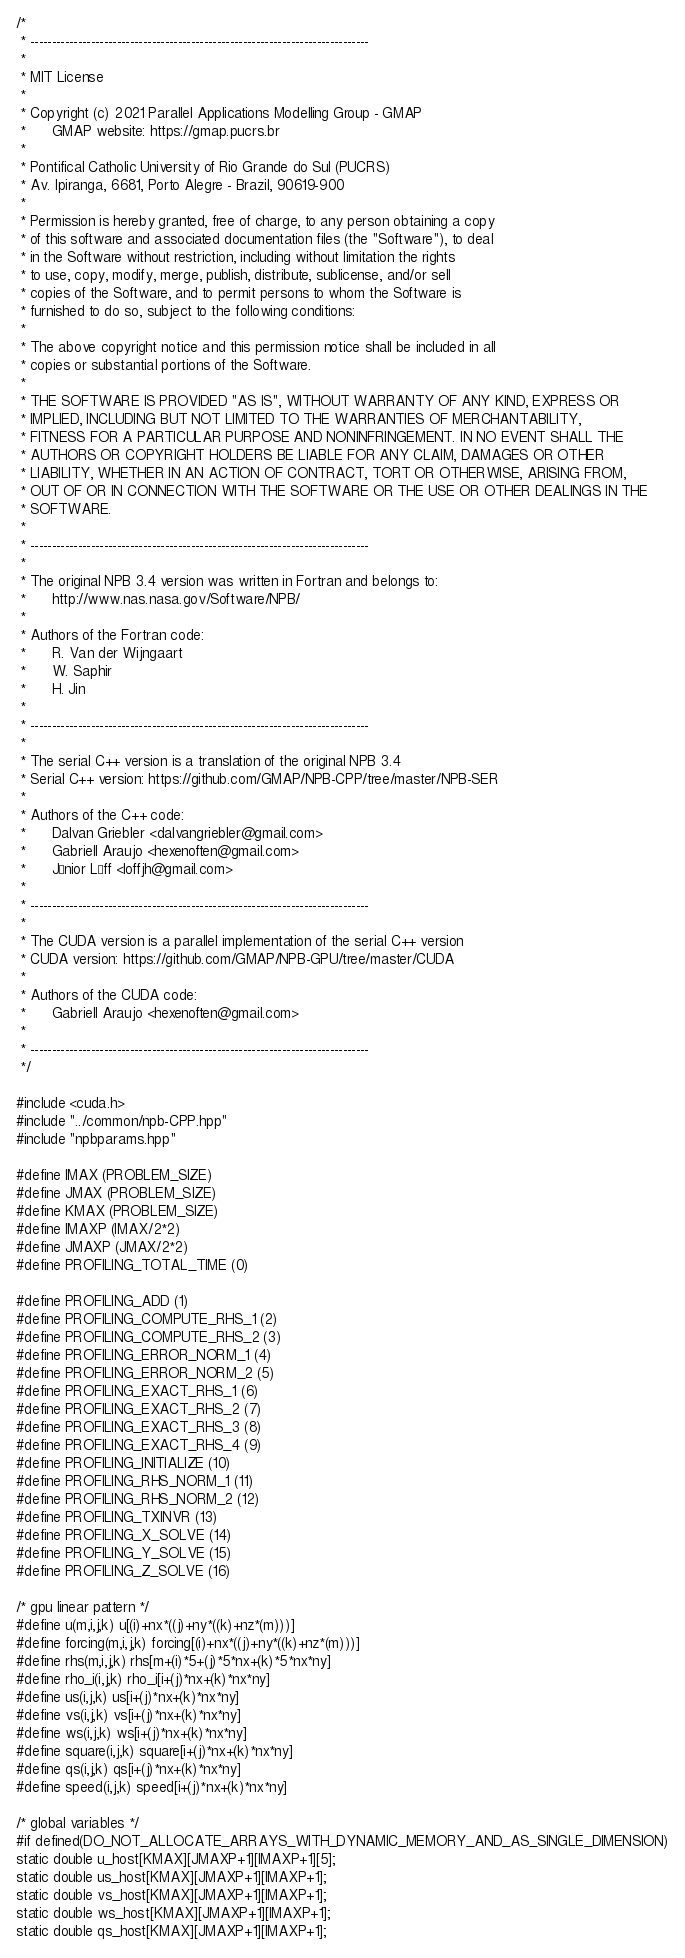Convert code to text. <code><loc_0><loc_0><loc_500><loc_500><_Cuda_>/* 
 * ------------------------------------------------------------------------------
 *
 * MIT License
 *
 * Copyright (c) 2021 Parallel Applications Modelling Group - GMAP
 *      GMAP website: https://gmap.pucrs.br
 *
 * Pontifical Catholic University of Rio Grande do Sul (PUCRS)
 * Av. Ipiranga, 6681, Porto Alegre - Brazil, 90619-900
 *
 * Permission is hereby granted, free of charge, to any person obtaining a copy
 * of this software and associated documentation files (the "Software"), to deal
 * in the Software without restriction, including without limitation the rights
 * to use, copy, modify, merge, publish, distribute, sublicense, and/or sell
 * copies of the Software, and to permit persons to whom the Software is
 * furnished to do so, subject to the following conditions:
 *
 * The above copyright notice and this permission notice shall be included in all
 * copies or substantial portions of the Software.
 *
 * THE SOFTWARE IS PROVIDED "AS IS", WITHOUT WARRANTY OF ANY KIND, EXPRESS OR
 * IMPLIED, INCLUDING BUT NOT LIMITED TO THE WARRANTIES OF MERCHANTABILITY,
 * FITNESS FOR A PARTICULAR PURPOSE AND NONINFRINGEMENT. IN NO EVENT SHALL THE
 * AUTHORS OR COPYRIGHT HOLDERS BE LIABLE FOR ANY CLAIM, DAMAGES OR OTHER
 * LIABILITY, WHETHER IN AN ACTION OF CONTRACT, TORT OR OTHERWISE, ARISING FROM,
 * OUT OF OR IN CONNECTION WITH THE SOFTWARE OR THE USE OR OTHER DEALINGS IN THE
 * SOFTWARE.
 *
 * ------------------------------------------------------------------------------
 *
 * The original NPB 3.4 version was written in Fortran and belongs to:
 *      http://www.nas.nasa.gov/Software/NPB/
 *
 * Authors of the Fortran code:
 *      R. Van der Wijngaart 
 *      W. Saphir 
 *      H. Jin
 *
 * ------------------------------------------------------------------------------
 *
 * The serial C++ version is a translation of the original NPB 3.4
 * Serial C++ version: https://github.com/GMAP/NPB-CPP/tree/master/NPB-SER
 *
 * Authors of the C++ code:
 *      Dalvan Griebler <dalvangriebler@gmail.com>
 *      Gabriell Araujo <hexenoften@gmail.com>
 *      Júnior Löff <loffjh@gmail.com>
 *
 * ------------------------------------------------------------------------------
 *
 * The CUDA version is a parallel implementation of the serial C++ version
 * CUDA version: https://github.com/GMAP/NPB-GPU/tree/master/CUDA
 *
 * Authors of the CUDA code:
 *      Gabriell Araujo <hexenoften@gmail.com>
 *
 * ------------------------------------------------------------------------------
 */

#include <cuda.h>
#include "../common/npb-CPP.hpp"
#include "npbparams.hpp"

#define IMAX (PROBLEM_SIZE)
#define JMAX (PROBLEM_SIZE)
#define KMAX (PROBLEM_SIZE)
#define IMAXP (IMAX/2*2)
#define JMAXP (JMAX/2*2)
#define PROFILING_TOTAL_TIME (0)

#define PROFILING_ADD (1)
#define PROFILING_COMPUTE_RHS_1 (2)
#define PROFILING_COMPUTE_RHS_2 (3)
#define PROFILING_ERROR_NORM_1 (4)
#define PROFILING_ERROR_NORM_2 (5)
#define PROFILING_EXACT_RHS_1 (6)
#define PROFILING_EXACT_RHS_2 (7)
#define PROFILING_EXACT_RHS_3 (8)
#define PROFILING_EXACT_RHS_4 (9)
#define PROFILING_INITIALIZE (10)
#define PROFILING_RHS_NORM_1 (11)
#define PROFILING_RHS_NORM_2 (12)
#define PROFILING_TXINVR (13)
#define PROFILING_X_SOLVE (14)
#define PROFILING_Y_SOLVE (15)
#define PROFILING_Z_SOLVE (16)

/* gpu linear pattern */
#define u(m,i,j,k) u[(i)+nx*((j)+ny*((k)+nz*(m)))]
#define forcing(m,i,j,k) forcing[(i)+nx*((j)+ny*((k)+nz*(m)))]
#define rhs(m,i,j,k) rhs[m+(i)*5+(j)*5*nx+(k)*5*nx*ny]
#define rho_i(i,j,k) rho_i[i+(j)*nx+(k)*nx*ny]
#define us(i,j,k) us[i+(j)*nx+(k)*nx*ny]
#define vs(i,j,k) vs[i+(j)*nx+(k)*nx*ny]
#define ws(i,j,k) ws[i+(j)*nx+(k)*nx*ny]
#define square(i,j,k) square[i+(j)*nx+(k)*nx*ny]
#define qs(i,j,k) qs[i+(j)*nx+(k)*nx*ny]
#define speed(i,j,k) speed[i+(j)*nx+(k)*nx*ny]

/* global variables */
#if defined(DO_NOT_ALLOCATE_ARRAYS_WITH_DYNAMIC_MEMORY_AND_AS_SINGLE_DIMENSION)
static double u_host[KMAX][JMAXP+1][IMAXP+1][5];
static double us_host[KMAX][JMAXP+1][IMAXP+1];
static double vs_host[KMAX][JMAXP+1][IMAXP+1];
static double ws_host[KMAX][JMAXP+1][IMAXP+1];
static double qs_host[KMAX][JMAXP+1][IMAXP+1];</code> 